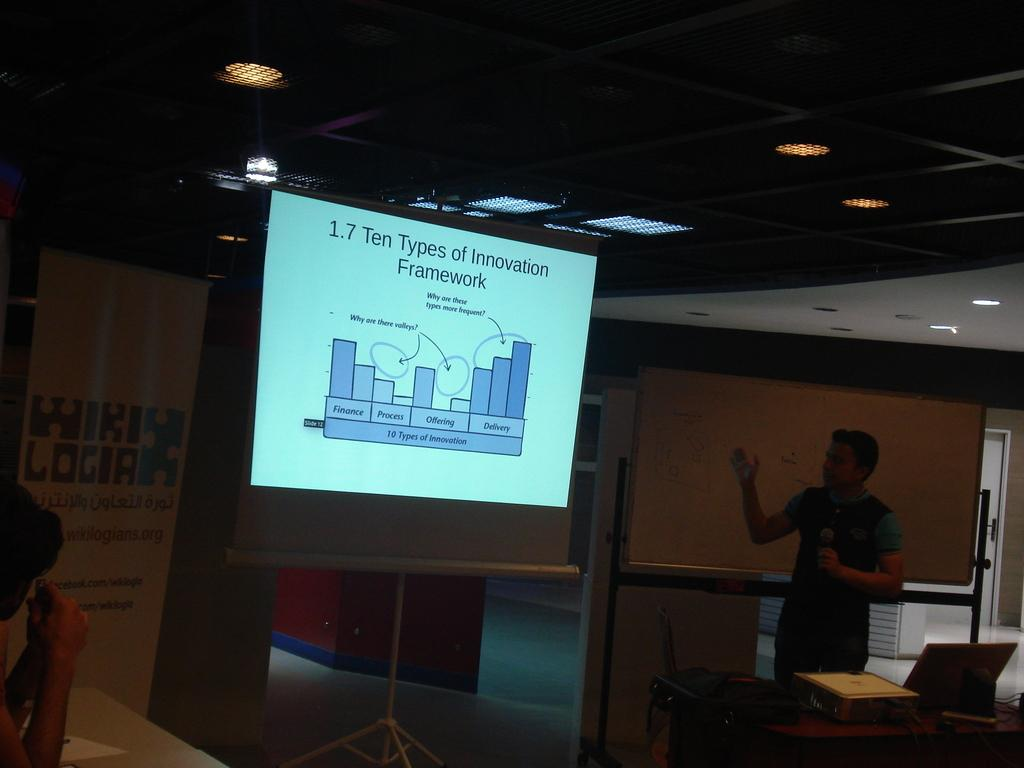What is the man in the image doing? The man is standing in the image and holding a microphone. What object is present in the image that is typically used for displaying visual information? There is a projector's screen in the image. Can you describe the people present in the image? There is at least one other person in the image besides the man holding the microphone. What type of crack is visible on the sidewalk in the image? There is no sidewalk present in the image, and therefore no crack can be observed. 